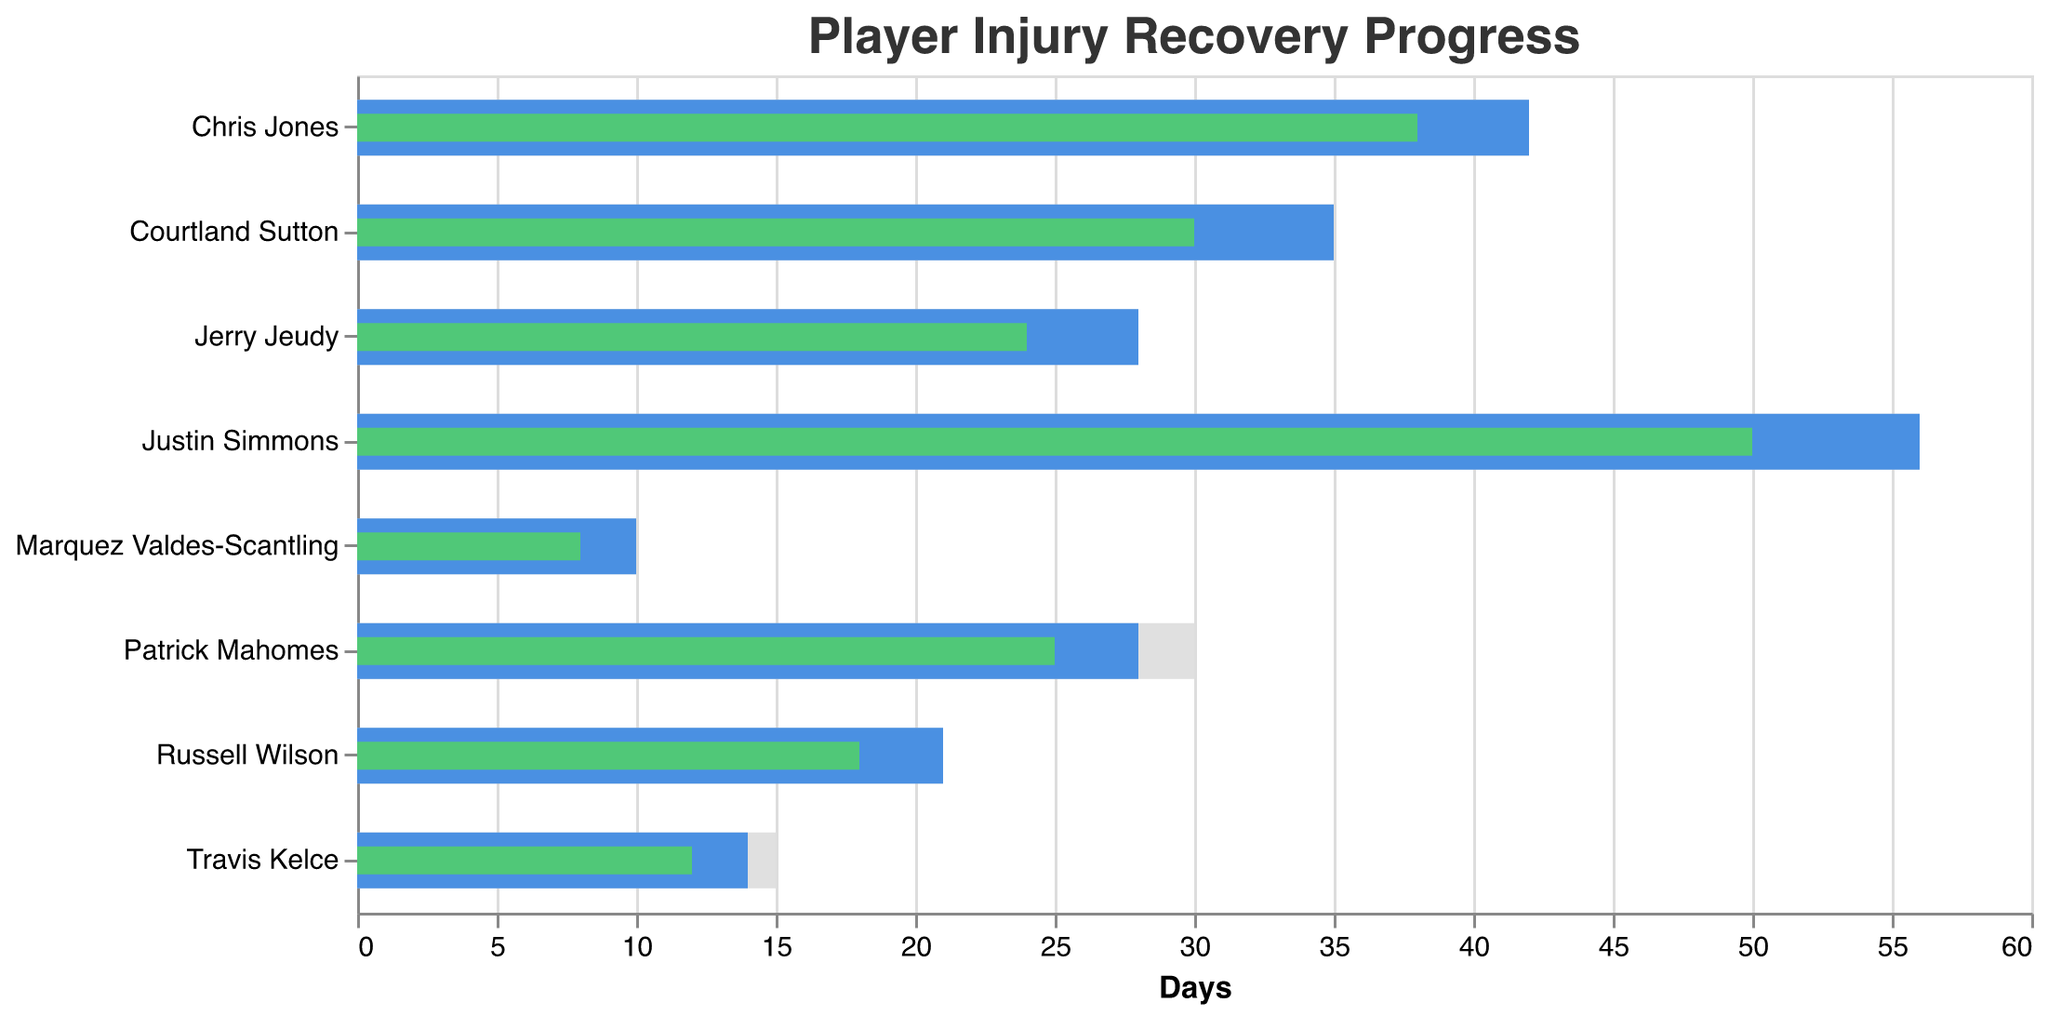What is the title of the chart? The title of the chart is placed on top and denotes the overall subject of the data being visualized. The title in this case reads "Player Injury Recovery Progress".
Answer: "Player Injury Recovery Progress" Which player has the smallest expected return time? By comparing the "Expected Return (Days)" bars, Marquez Valdes-Scantling from the Kansas City Chiefs has the smallest expected return time of 10 days.
Answer: Marquez Valdes-Scantling How does Justin Simmons' actual progress compare to his target? Justin Simmons' target return date is 56 days, according to the target bar. His actual progress stands at 50 days, as shown by the green bar. Thus, he has 6 more days to reach his target.
Answer: 6 days left Compare the actual recovery progress of Patrick Mahomes and Russell Wilson. The green bars indicate the actual progress. Patrick Mahomes has progressed for 25 days, whereas Russell Wilson has progressed for 18 days. Patrick Mahomes' recovery is 7 days ahead of Russell Wilson's.
Answer: Patrick Mahomes 7 days ahead Which player's recovery progress is closest to their expected return? By comparing the length differences between the "Expected Return (Days)" bars and their corresponding "Actual Progress (Days)" bars, Russell Wilson's progress (18 days) is closest to his expected return of 21 days, making the difference only 3 days.
Answer: Russell Wilson Calculate the average expected return time for the Kansas City Chiefs players. To get the average, sum the expected return times for Chiefs players (28 + 14 + 42 + 10) and divide by the number of players (4). This results in (28 + 14 + 42 + 10) / 4 = 94 / 4 = 23.5 days.
Answer: 23.5 days Which Denver Broncos player has the longest expected return time? By analyzing the "Expected Return (Days)" bars, Justin Simmons of the Denver Broncos has the longest expected return time at 56 days.
Answer: Justin Simmons Compare the expected return times of Travis Kelce and Jerry Jeudy. Who has a shorter time? Travis Kelce of the Kansas City Chiefs has an expected return time of 14 days, whereas Jerry Jeudy of the Denver Broncos has an expected return time of 28 days. Therefore, Travis Kelce has a shorter expected return time.
Answer: Travis Kelce Which team has more players who have an actual progress bar shorter than 20 days? Identify players with "Actual Progress (Days)" bars less than 20 days: Kansas City Chiefs (Patrick Mahomes, Travis Kelce, Marquez Valdes-Scantling - 3 players) and Denver Broncos (Russell Wilson, Jerry Jeudy - 2 players). The Chiefs have more such players.
Answer: Kansas City Chiefs How much earlier did Chris Jones progress compared to his target return date? Chris Jones' target return date is 42 days, and his actual progress is 38 days. The difference is 42 - 38 = 4 days earlier.
Answer: 4 days earlier 